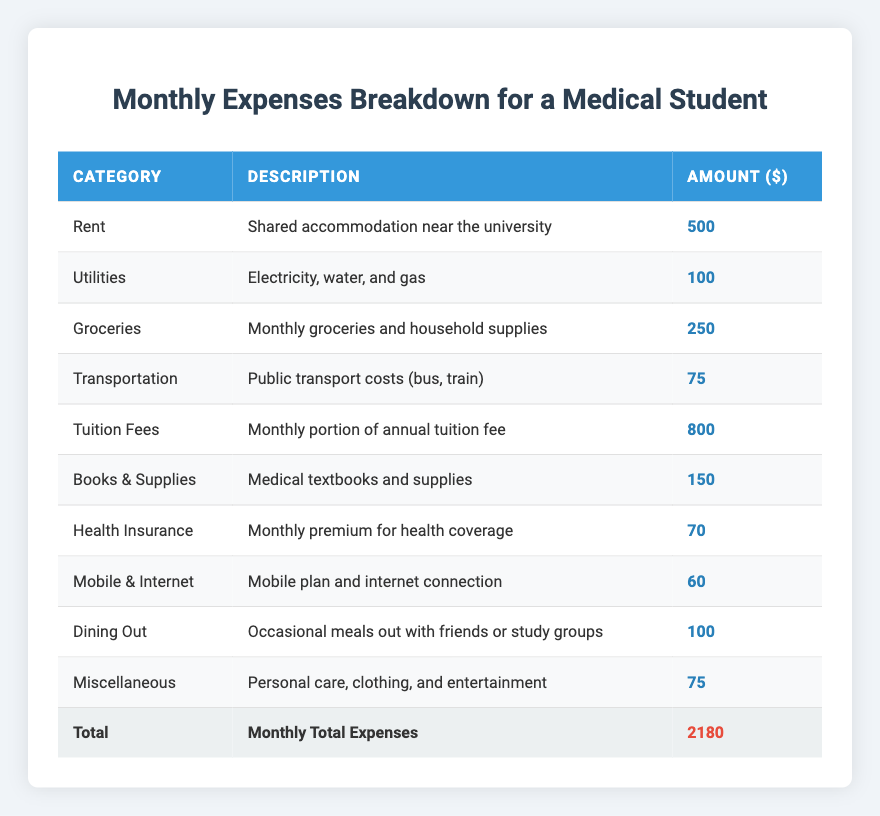What is the total amount spent on Rent and Utilities? The amount for Rent is 500, and for Utilities, it is 100. Adding these together: 500 + 100 = 600.
Answer: 600 How much do Groceries cost per month? The table states the cost for Groceries is listed as 250.
Answer: 250 What is the amount spent on Health Insurance? The table shows the amount for Health Insurance as 70.
Answer: 70 Is the monthly expense on Books & Supplies greater than the expense on Dining Out? The amount for Books & Supplies is 150, and the amount for Dining Out is 100. Since 150 is greater than 100, the statement is true.
Answer: Yes What are the total expenses on Transportation and Mobile & Internet combined? The expense on Transportation is 75, and Mobile & Internet is 60. Adding these figures together: 75 + 60 = 135.
Answer: 135 What is the average spending across all categories? There are 10 categories with a total expense of 2180. To find the average, divide 2180 by 10, which equals 218.
Answer: 218 Do the total expenses exceed 2000? The total amount is 2180, which is greater than 2000. Therefore, the answer is yes.
Answer: Yes What is the difference between the highest expense (Tuition Fees) and the lowest expense (Health Insurance)? The highest expense is 800 (Tuition Fees) and the lowest is 70 (Health Insurance). The difference is calculated as 800 - 70 = 730.
Answer: 730 How much more is spent on Tuition Fees compared to Utilities? The Tuition Fees are 800, and Utilities are 100. Subtracting these gives 800 - 100 = 700.
Answer: 700 What is the total spent on all Medical student expenses this month? The total of all the expenses is already provided in the table as 2180, representing the sum of each category.
Answer: 2180 